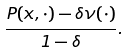Convert formula to latex. <formula><loc_0><loc_0><loc_500><loc_500>\frac { P ( x , \cdot ) - \delta \nu ( \cdot ) } { 1 - \delta } .</formula> 